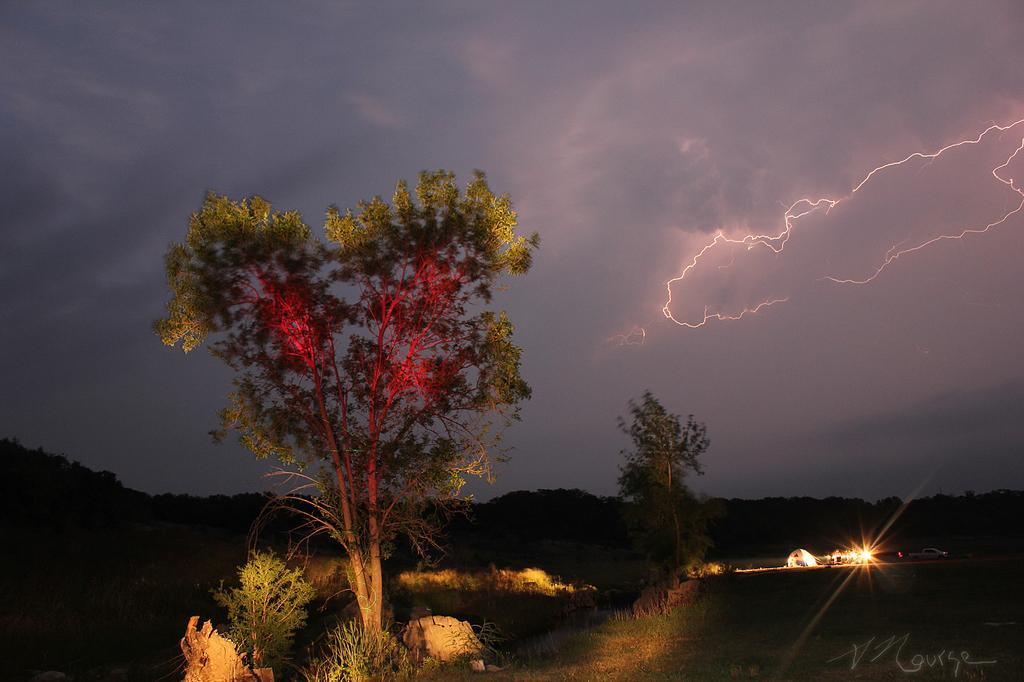Please provide a concise description of this image. In this picture we can see a tent and few vehicles on the path. We can see some trees and plants. There is lightning in the sky. Sky is cloudy. 